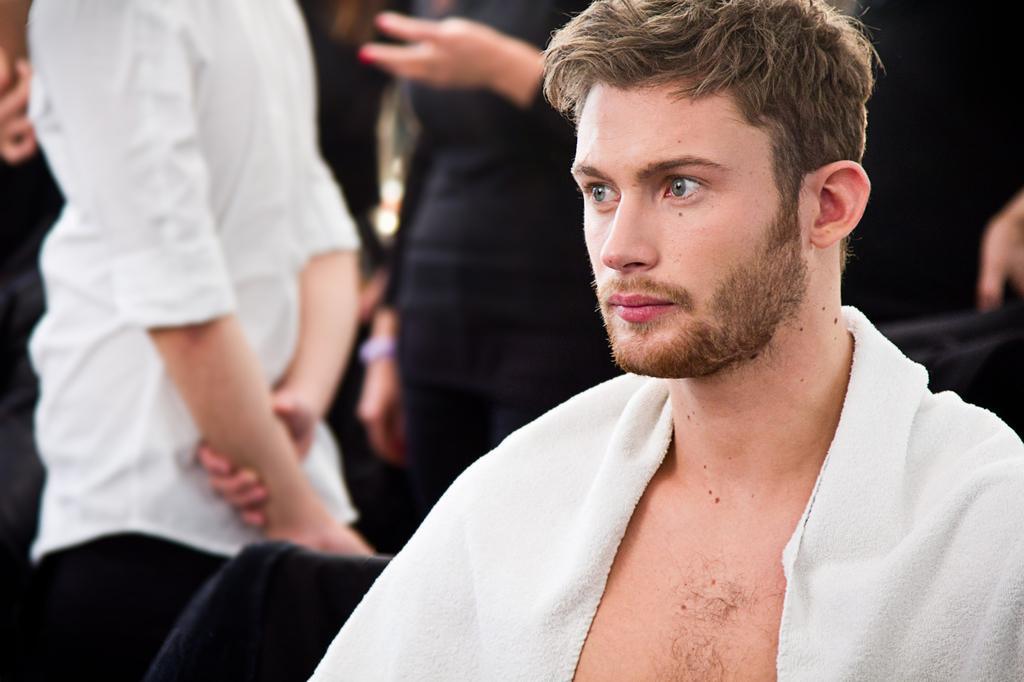Could you give a brief overview of what you see in this image? In this image in the foreground there is one man who is sitting, and in the background there are some people who are standing and also there are some chairs. 